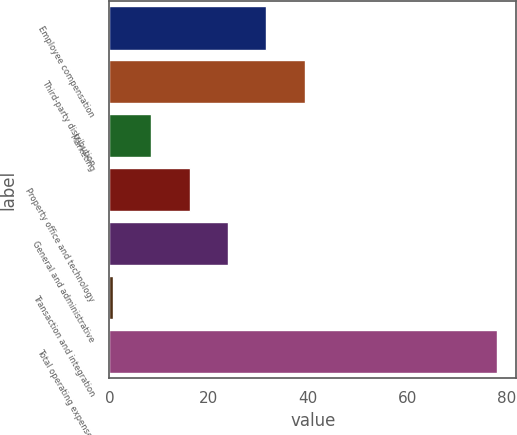Convert chart to OTSL. <chart><loc_0><loc_0><loc_500><loc_500><bar_chart><fcel>Employee compensation<fcel>Third-party distribution<fcel>Marketing<fcel>Property office and technology<fcel>General and administrative<fcel>Transaction and integration<fcel>Total operating expenses<nl><fcel>31.62<fcel>39.35<fcel>8.43<fcel>16.16<fcel>23.89<fcel>0.7<fcel>78<nl></chart> 